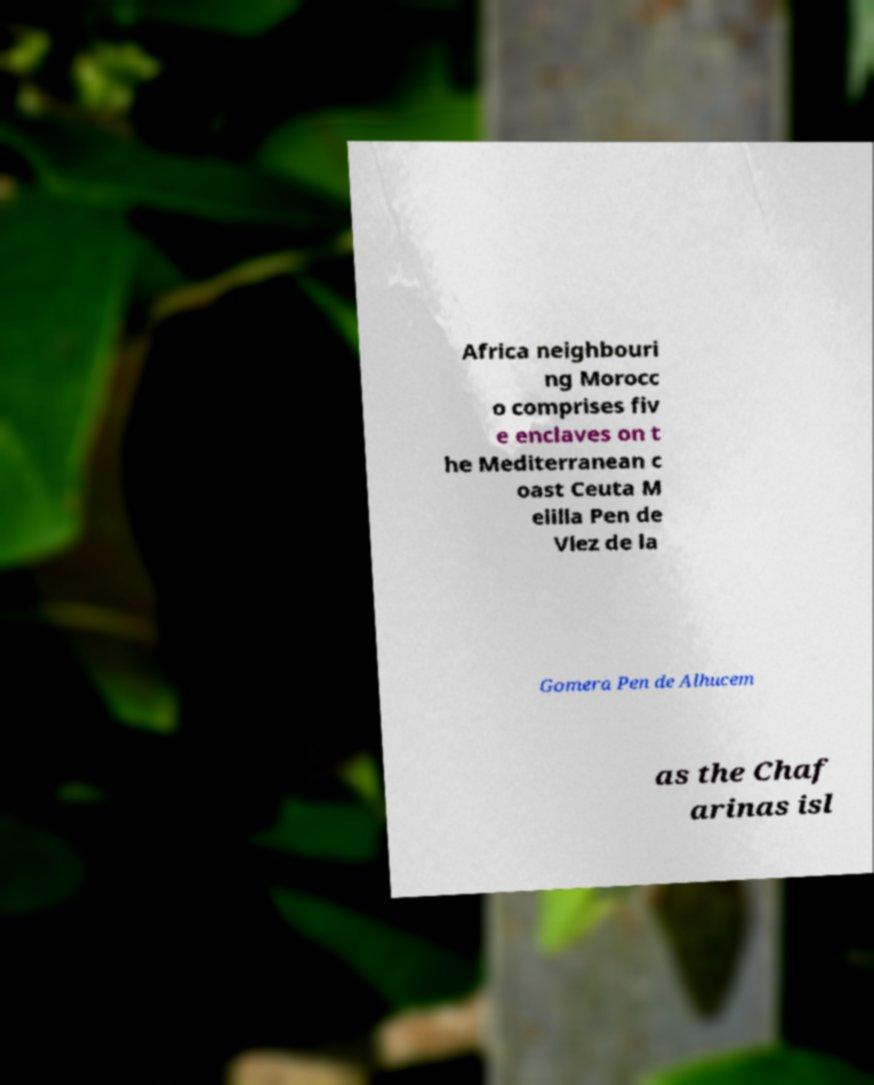Could you extract and type out the text from this image? Africa neighbouri ng Morocc o comprises fiv e enclaves on t he Mediterranean c oast Ceuta M elilla Pen de Vlez de la Gomera Pen de Alhucem as the Chaf arinas isl 